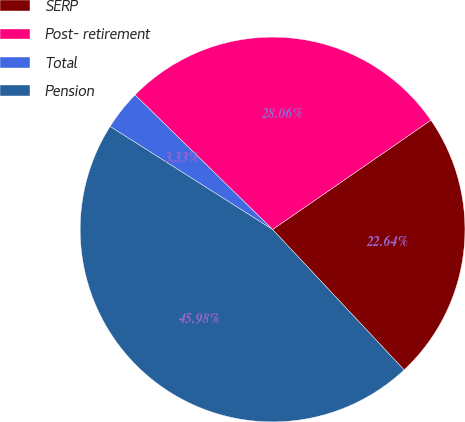Convert chart to OTSL. <chart><loc_0><loc_0><loc_500><loc_500><pie_chart><fcel>SERP<fcel>Post- retirement<fcel>Total<fcel>Pension<nl><fcel>22.64%<fcel>28.06%<fcel>3.33%<fcel>45.98%<nl></chart> 